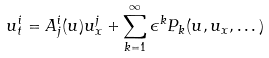<formula> <loc_0><loc_0><loc_500><loc_500>u ^ { i } _ { t } = A ^ { i } _ { j } ( u ) u ^ { j } _ { x } + \sum _ { k = 1 } ^ { \infty } \epsilon ^ { k } P _ { k } ( u , u _ { x } , \dots )</formula> 